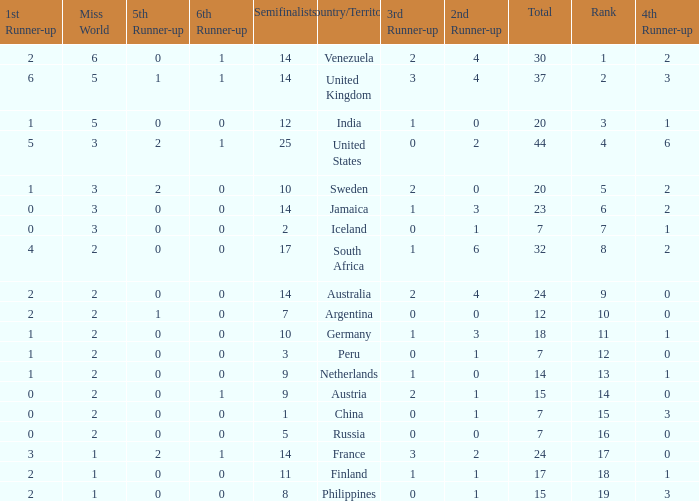What is Venezuela's total rank? 30.0. 